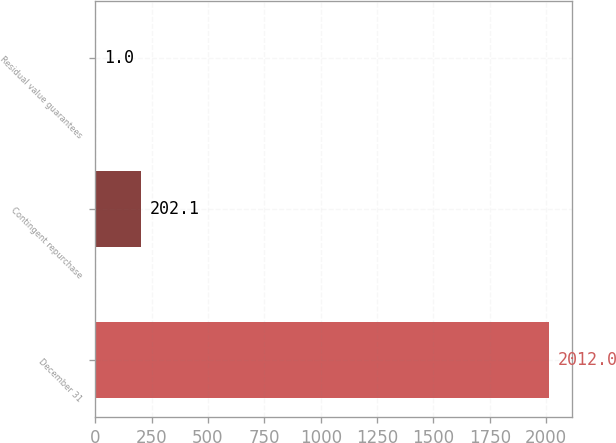<chart> <loc_0><loc_0><loc_500><loc_500><bar_chart><fcel>December 31<fcel>Contingent repurchase<fcel>Residual value guarantees<nl><fcel>2012<fcel>202.1<fcel>1<nl></chart> 